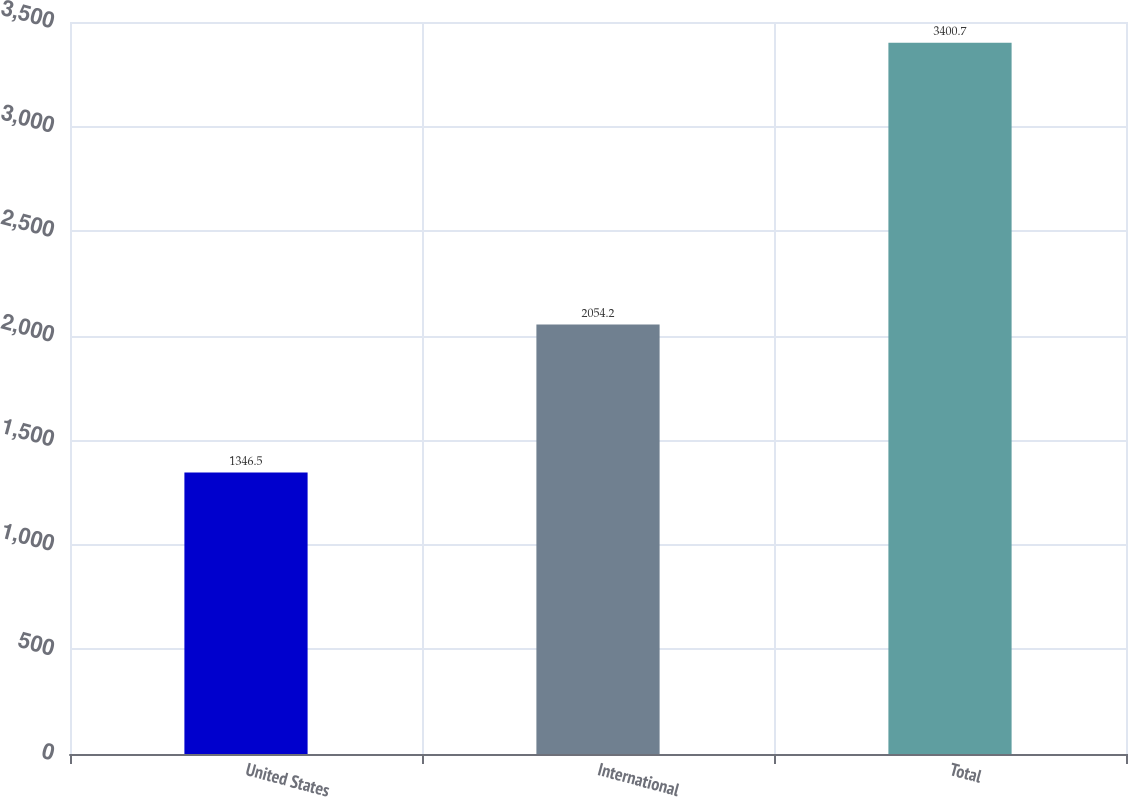<chart> <loc_0><loc_0><loc_500><loc_500><bar_chart><fcel>United States<fcel>International<fcel>Total<nl><fcel>1346.5<fcel>2054.2<fcel>3400.7<nl></chart> 